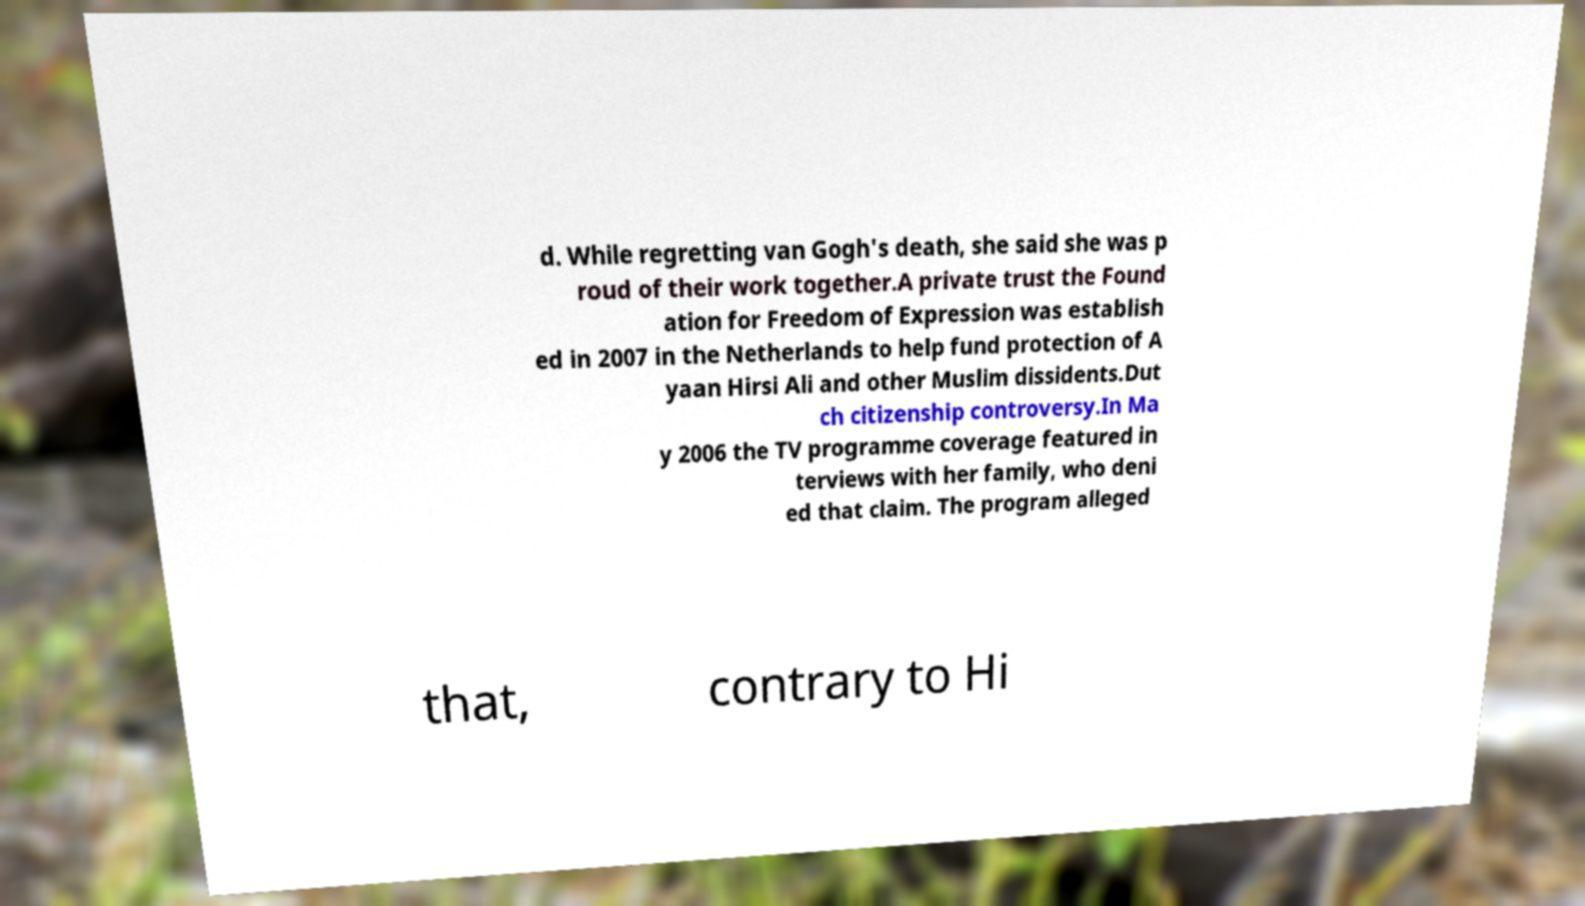Can you accurately transcribe the text from the provided image for me? d. While regretting van Gogh's death, she said she was p roud of their work together.A private trust the Found ation for Freedom of Expression was establish ed in 2007 in the Netherlands to help fund protection of A yaan Hirsi Ali and other Muslim dissidents.Dut ch citizenship controversy.In Ma y 2006 the TV programme coverage featured in terviews with her family, who deni ed that claim. The program alleged that, contrary to Hi 